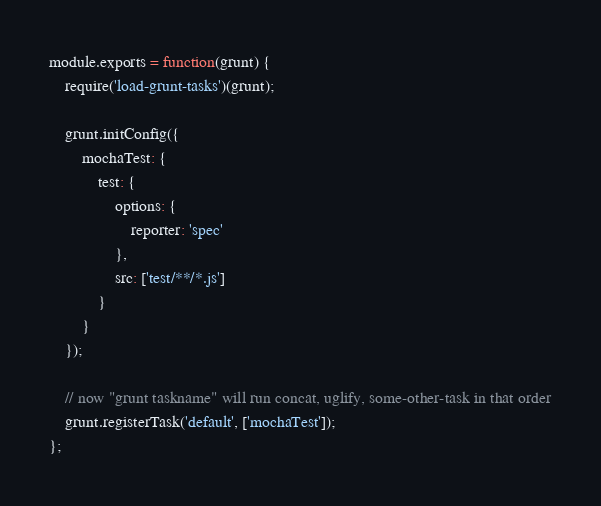Convert code to text. <code><loc_0><loc_0><loc_500><loc_500><_JavaScript_>module.exports = function(grunt) {
    require('load-grunt-tasks')(grunt);
    
    grunt.initConfig({
        mochaTest: {
            test: {
                options: {
                    reporter: 'spec'
                },
                src: ['test/**/*.js']
            }
        }
    });

    // now "grunt taskname" will run concat, uglify, some-other-task in that order
    grunt.registerTask('default', ['mochaTest']);
};</code> 